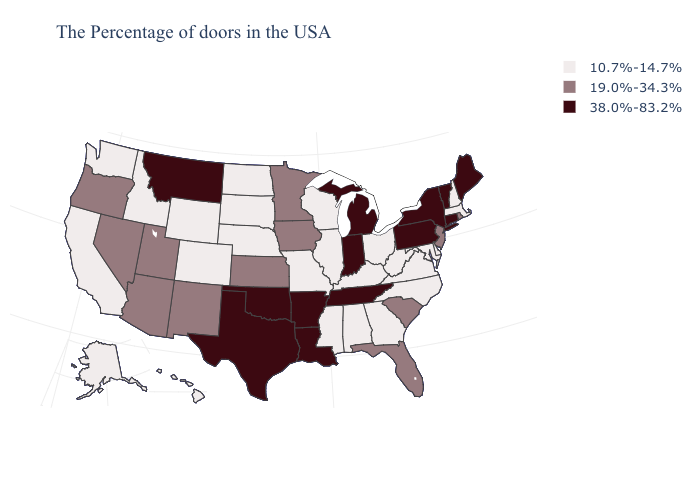Does New Mexico have the same value as Arizona?
Write a very short answer. Yes. Is the legend a continuous bar?
Keep it brief. No. Does the first symbol in the legend represent the smallest category?
Answer briefly. Yes. Among the states that border South Dakota , does Nebraska have the lowest value?
Keep it brief. Yes. Among the states that border Vermont , does Massachusetts have the lowest value?
Write a very short answer. Yes. Does the map have missing data?
Write a very short answer. No. Among the states that border Iowa , does Minnesota have the highest value?
Give a very brief answer. Yes. Name the states that have a value in the range 10.7%-14.7%?
Quick response, please. Massachusetts, New Hampshire, Delaware, Maryland, Virginia, North Carolina, West Virginia, Ohio, Georgia, Kentucky, Alabama, Wisconsin, Illinois, Mississippi, Missouri, Nebraska, South Dakota, North Dakota, Wyoming, Colorado, Idaho, California, Washington, Alaska, Hawaii. Among the states that border Kansas , does Missouri have the highest value?
Short answer required. No. What is the value of Arkansas?
Keep it brief. 38.0%-83.2%. How many symbols are there in the legend?
Quick response, please. 3. Name the states that have a value in the range 38.0%-83.2%?
Short answer required. Maine, Vermont, Connecticut, New York, Pennsylvania, Michigan, Indiana, Tennessee, Louisiana, Arkansas, Oklahoma, Texas, Montana. Name the states that have a value in the range 10.7%-14.7%?
Write a very short answer. Massachusetts, New Hampshire, Delaware, Maryland, Virginia, North Carolina, West Virginia, Ohio, Georgia, Kentucky, Alabama, Wisconsin, Illinois, Mississippi, Missouri, Nebraska, South Dakota, North Dakota, Wyoming, Colorado, Idaho, California, Washington, Alaska, Hawaii. What is the highest value in the MidWest ?
Concise answer only. 38.0%-83.2%. 